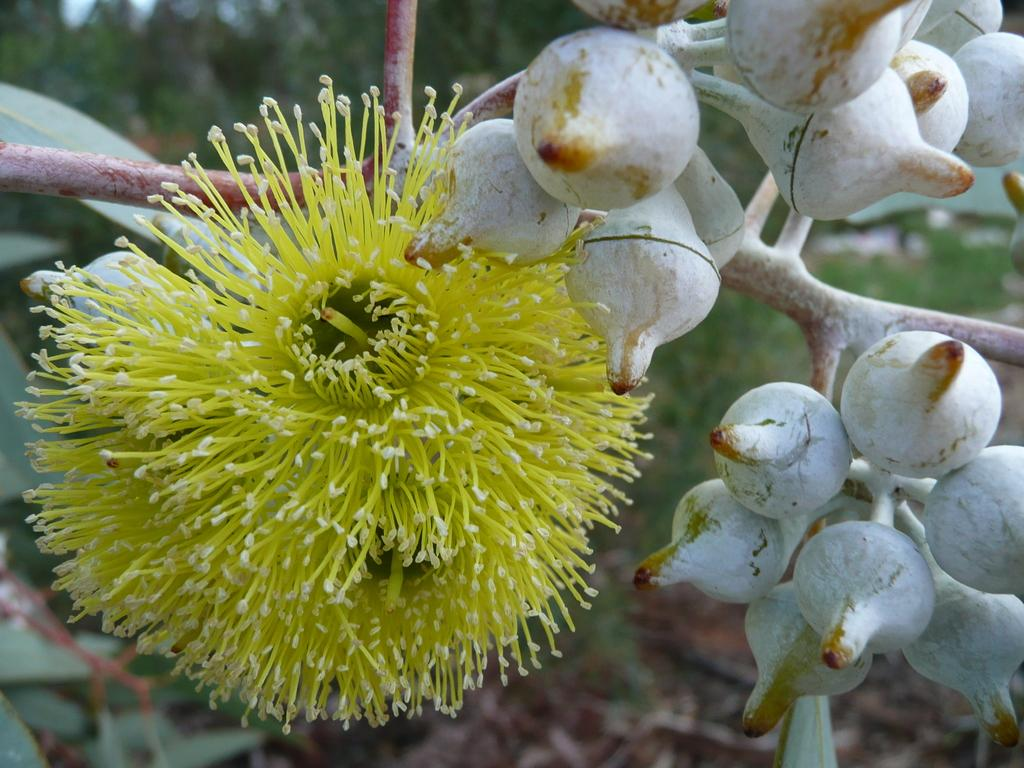What type of plants can be seen in the image? There are flowers in the image. Can you describe the flowers in more detail? There are buds on the stem in the image. What can be seen in the background of the image? There are trees in the background of the image. How many chickens are sitting on the table in the image? There are no chickens present in the image. What type of meal is being prepared in the basin in the image? There is no basin or meal preparation visible in the image. 